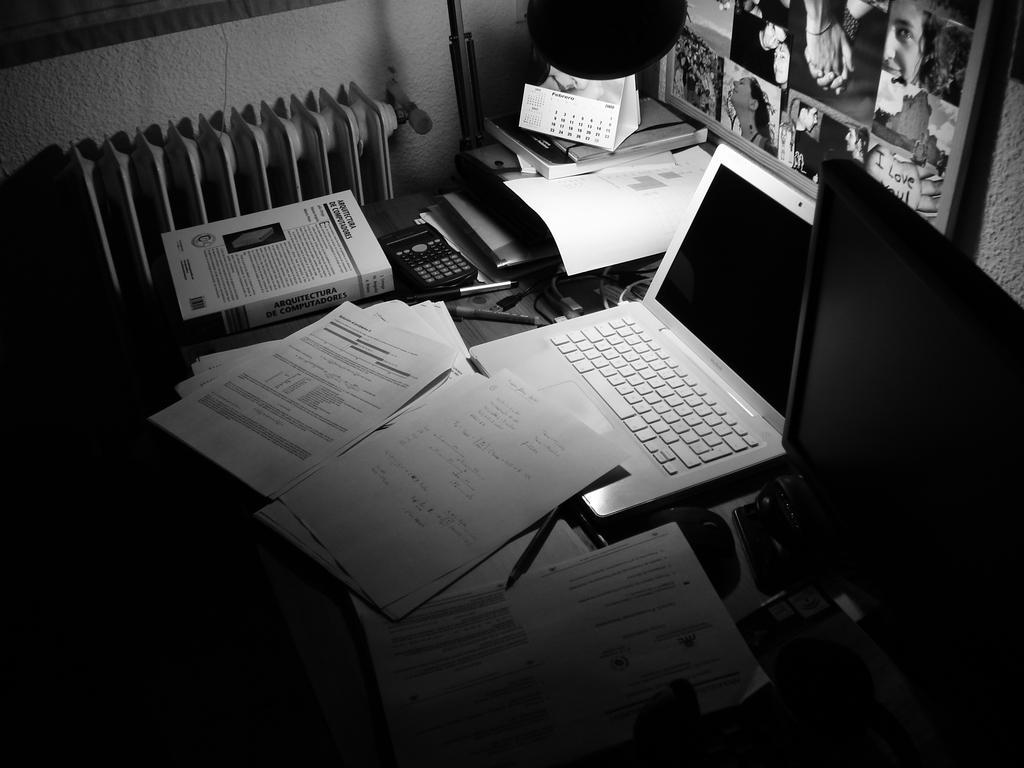In one or two sentences, can you explain what this image depicts? In the foreground of this black and white image, there are papers, pens, pencil, book, calculator, laptop, monitor and many objects are on the table. In the background, there is an object and the frame on the wall. 